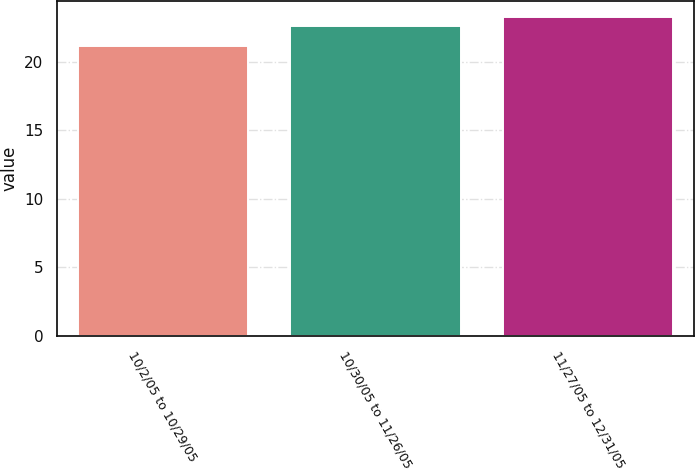Convert chart to OTSL. <chart><loc_0><loc_0><loc_500><loc_500><bar_chart><fcel>10/2/05 to 10/29/05<fcel>10/30/05 to 11/26/05<fcel>11/27/05 to 12/31/05<nl><fcel>21.16<fcel>22.59<fcel>23.26<nl></chart> 